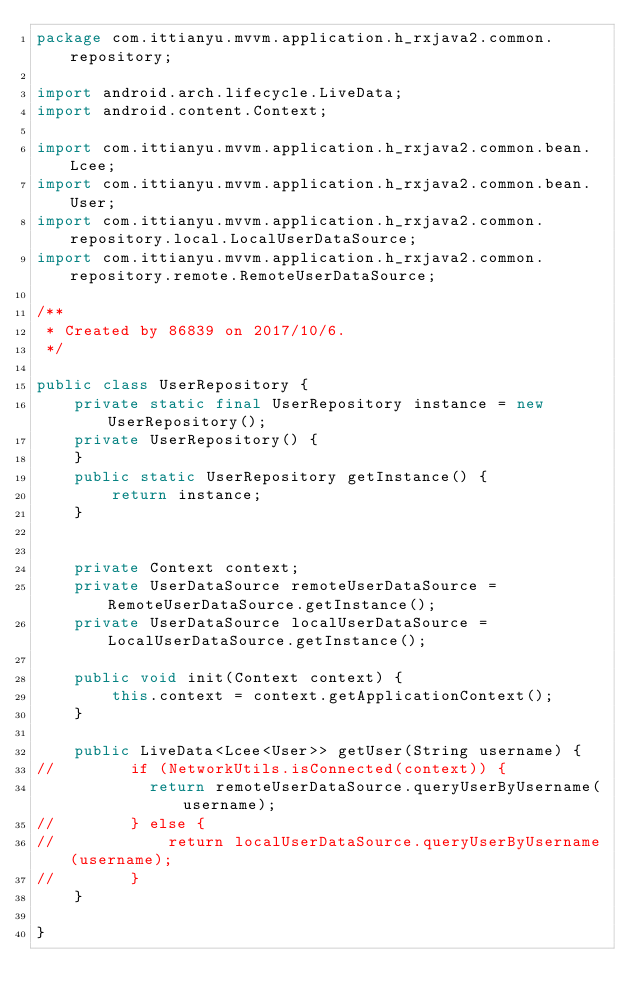<code> <loc_0><loc_0><loc_500><loc_500><_Java_>package com.ittianyu.mvvm.application.h_rxjava2.common.repository;

import android.arch.lifecycle.LiveData;
import android.content.Context;

import com.ittianyu.mvvm.application.h_rxjava2.common.bean.Lcee;
import com.ittianyu.mvvm.application.h_rxjava2.common.bean.User;
import com.ittianyu.mvvm.application.h_rxjava2.common.repository.local.LocalUserDataSource;
import com.ittianyu.mvvm.application.h_rxjava2.common.repository.remote.RemoteUserDataSource;

/**
 * Created by 86839 on 2017/10/6.
 */

public class UserRepository {
    private static final UserRepository instance = new UserRepository();
    private UserRepository() {
    }
    public static UserRepository getInstance() {
        return instance;
    }


    private Context context;
    private UserDataSource remoteUserDataSource = RemoteUserDataSource.getInstance();
    private UserDataSource localUserDataSource = LocalUserDataSource.getInstance();

    public void init(Context context) {
        this.context = context.getApplicationContext();
    }

    public LiveData<Lcee<User>> getUser(String username) {
//        if (NetworkUtils.isConnected(context)) {
            return remoteUserDataSource.queryUserByUsername(username);
//        } else {
//            return localUserDataSource.queryUserByUsername(username);
//        }
    }

}
</code> 